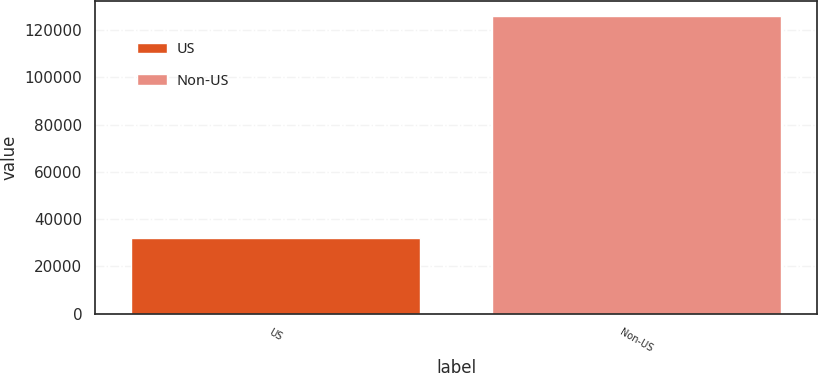Convert chart to OTSL. <chart><loc_0><loc_0><loc_500><loc_500><bar_chart><fcel>US<fcel>Non-US<nl><fcel>31783<fcel>126072<nl></chart> 